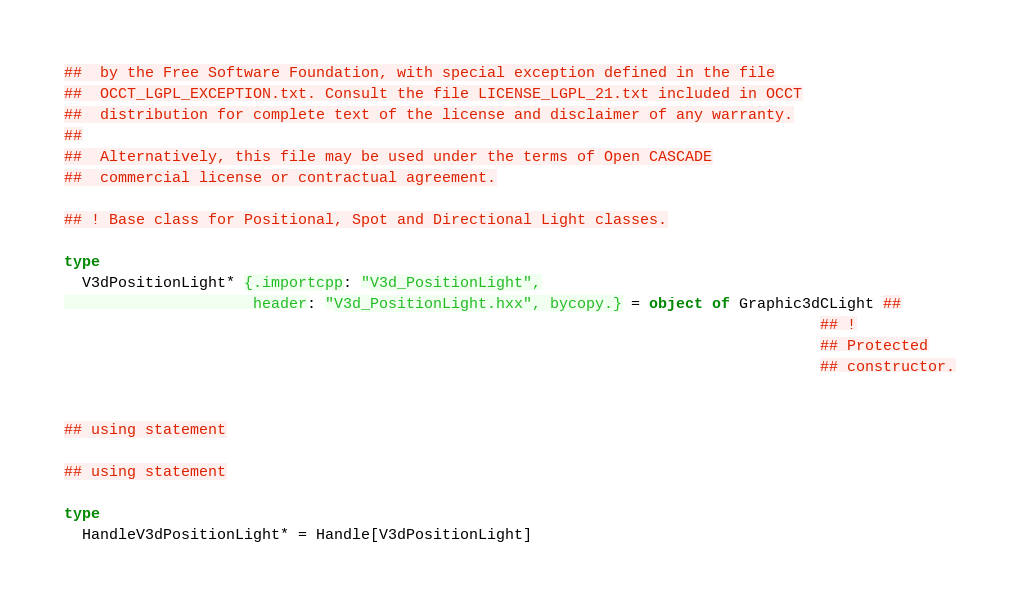Convert code to text. <code><loc_0><loc_0><loc_500><loc_500><_Nim_>##  by the Free Software Foundation, with special exception defined in the file
##  OCCT_LGPL_EXCEPTION.txt. Consult the file LICENSE_LGPL_21.txt included in OCCT
##  distribution for complete text of the license and disclaimer of any warranty.
##
##  Alternatively, this file may be used under the terms of Open CASCADE
##  commercial license or contractual agreement.

## ! Base class for Positional, Spot and Directional Light classes.

type
  V3dPositionLight* {.importcpp: "V3d_PositionLight",
                     header: "V3d_PositionLight.hxx", bycopy.} = object of Graphic3dCLight ##
                                                                                    ## !
                                                                                    ## Protected
                                                                                    ## constructor.


## using statement

## using statement

type
  HandleV3dPositionLight* = Handle[V3dPositionLight]
</code> 